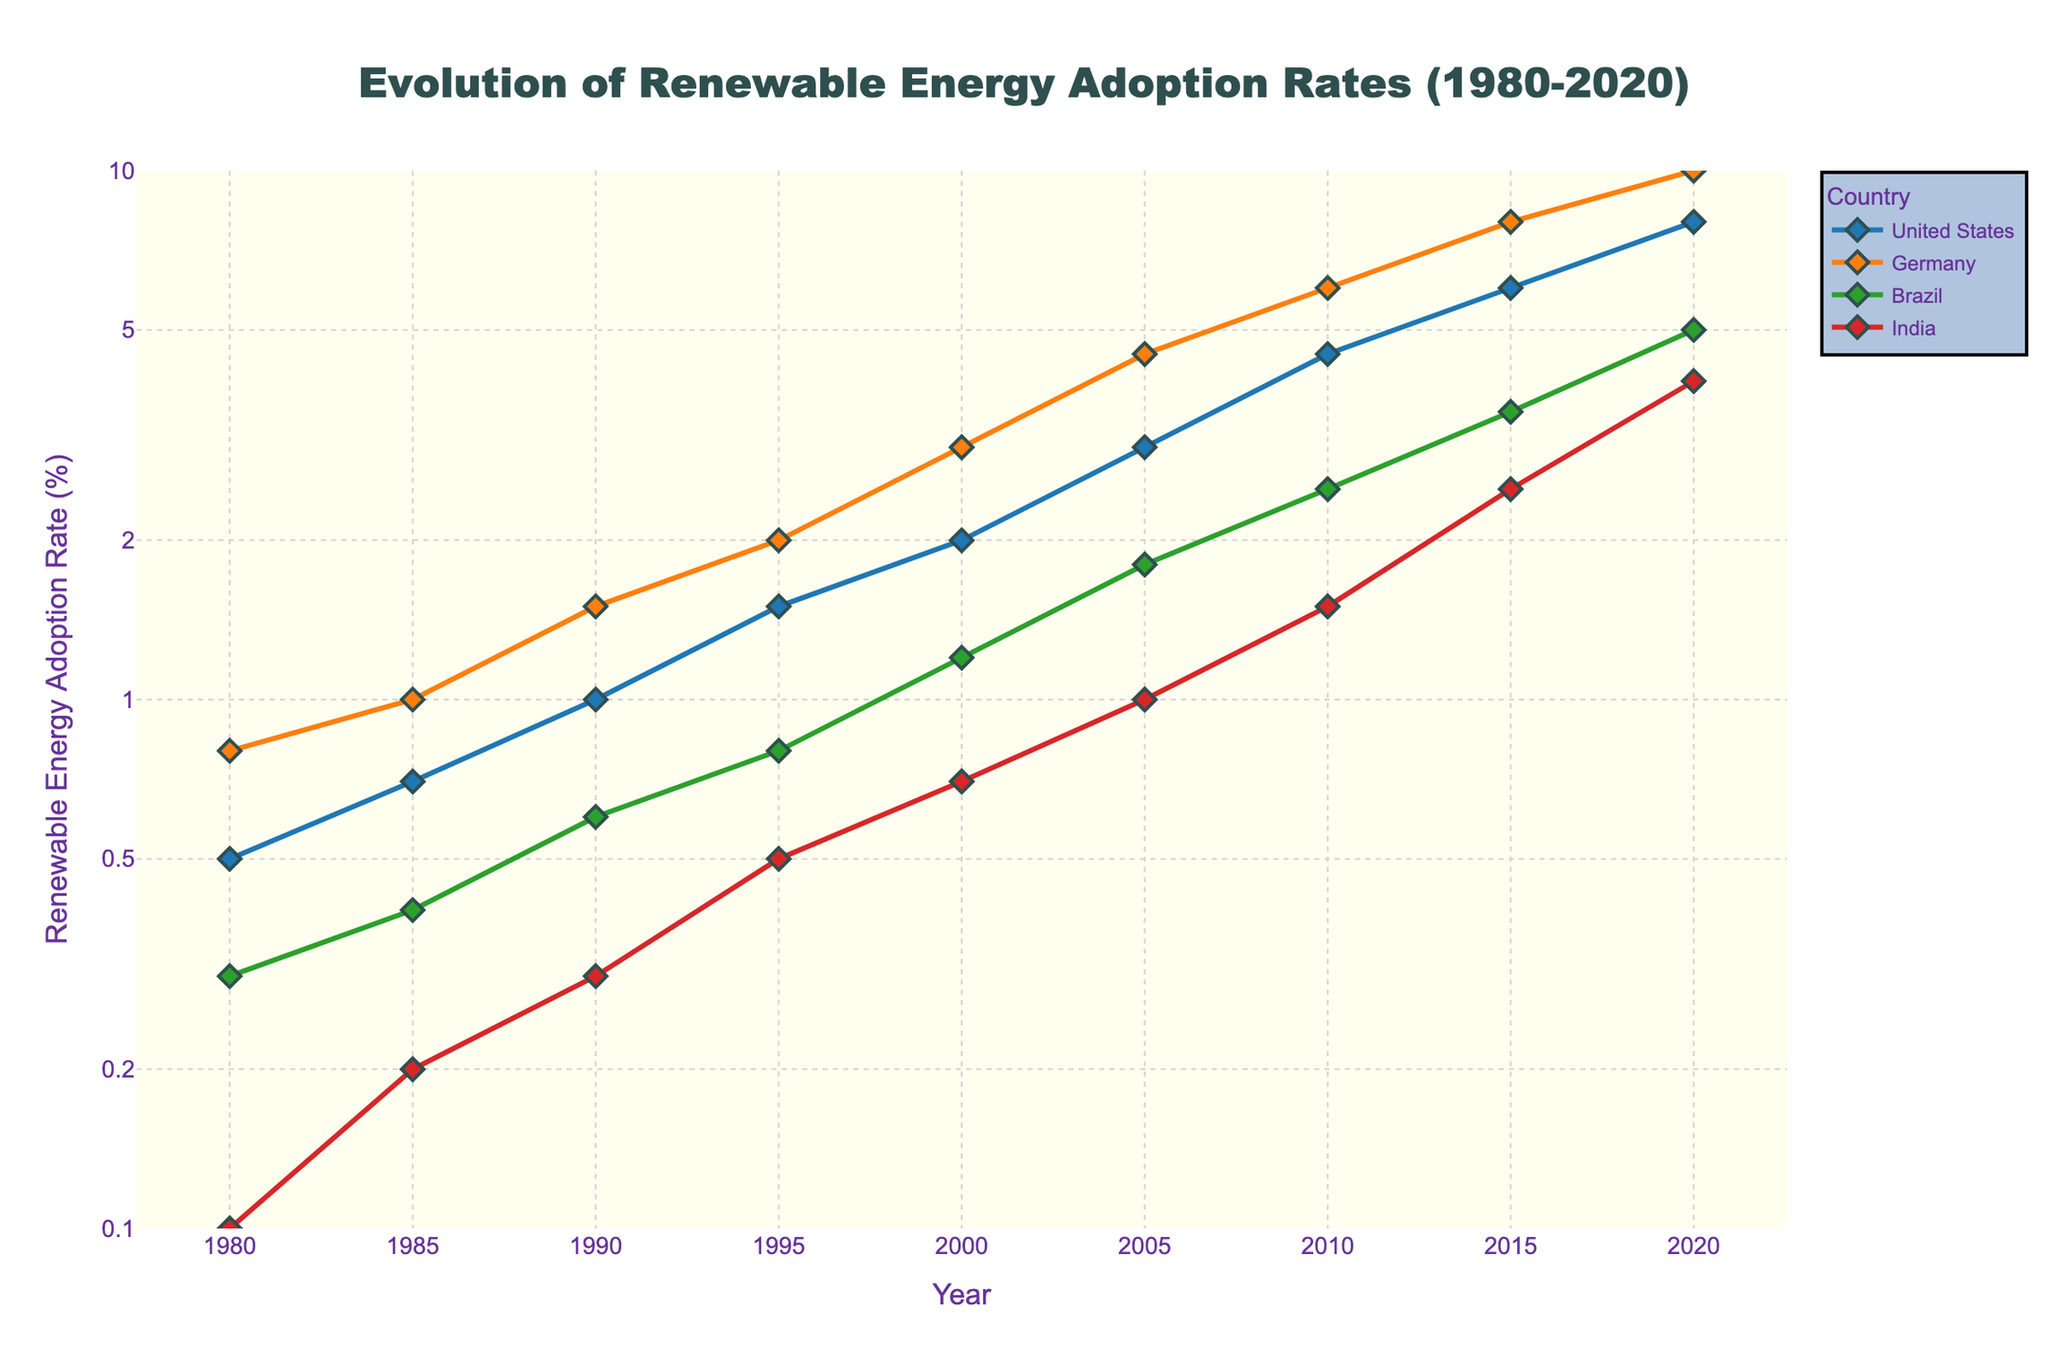What is the title of the plot? The title is displayed at the top of the figure, centered and highlighted in bold font.
Answer: Evolution of Renewable Energy Adoption Rates (1980-2020) Which country had the highest renewable energy adoption rate in 2020? The plot shows Germany with the highest data point in 2020.
Answer: Germany What is the y-axis range in log scale for the plot? The y-axis ranges from 0.1 to 10 and this range is indicated by the log tick marks on the y-axis.
Answer: 0.1 to 10 How does the renewable energy adoption rate in Brazil in 2000 compare to that in 2020? In 2000, Brazil's adoption rate is approximately 1.2, and in 2020 it is approximately 5.0. Hence, Brazil's adoption rate has increased significantly from 2000 to 2020.
Answer: Increased Between 1990 and 1995, which country's adoption rate increased by the largest factor? By examining the graph, Germany's rate increased from 1.5 to 2.0, United States from 1.0 to 1.5, Brazil from 0.6 to 0.8, and India from 0.3 to 0.5. The largest relative increase in terms of factor is India, from 0.3 to 0.5, which is a factor increase of approximately 1.67.
Answer: India Which country displayed the most consistent growth in renewable energy adoption from 1980 to 2020? Germany shows the most consistent linear increase when viewed on the log scale plot. Other countries show more varied growth rates.
Answer: Germany How many countries are represented in the plot? The legend of the plot includes four countries.
Answer: Four What is the difference in renewable energy adoption rates between the United States and India in 2005? In 2005, the United States' adoption rate is approximately 3.0, and India's rate is approximately 1.0. The difference is 3.0 - 1.0 = 2.0.
Answer: 2.0 Did any country have a renewable energy adoption rate lower than 1% in 2020? On the log scale, all countries in 2020 have data points above 1%, indicating no country has a rate lower than 1%.
Answer: No From 1980 to 2010, which country had the largest increase in renewable energy adoption rate? By comparing the earliest values to 2010, Germany increased from 0.8 to 6.0, which is a factor of 7.5 times. This is the largest increase among the countries shown.
Answer: Germany 